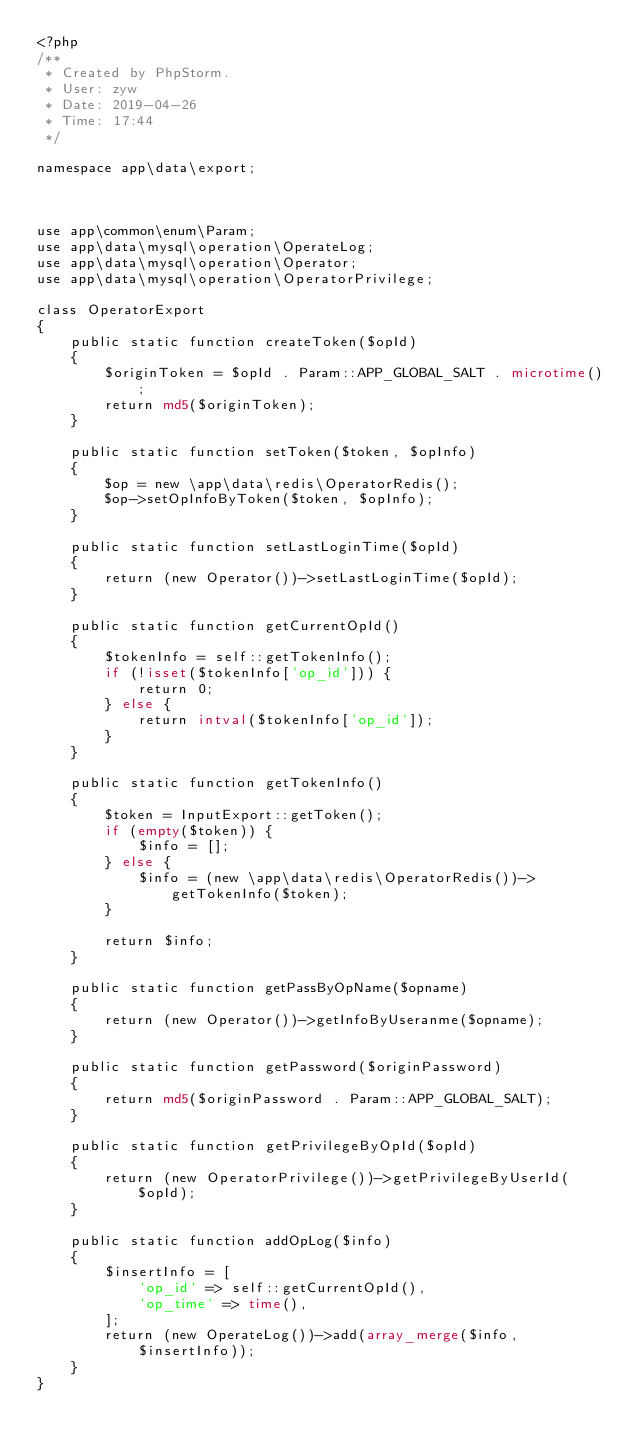Convert code to text. <code><loc_0><loc_0><loc_500><loc_500><_PHP_><?php
/**
 * Created by PhpStorm.
 * User: zyw
 * Date: 2019-04-26
 * Time: 17:44
 */

namespace app\data\export;



use app\common\enum\Param;
use app\data\mysql\operation\OperateLog;
use app\data\mysql\operation\Operator;
use app\data\mysql\operation\OperatorPrivilege;

class OperatorExport
{
    public static function createToken($opId)
    {
        $originToken = $opId . Param::APP_GLOBAL_SALT . microtime();
        return md5($originToken);
    }

    public static function setToken($token, $opInfo)
    {
        $op = new \app\data\redis\OperatorRedis();
        $op->setOpInfoByToken($token, $opInfo);
    }

    public static function setLastLoginTime($opId)
    {
        return (new Operator())->setLastLoginTime($opId);
    }

    public static function getCurrentOpId()
    {
        $tokenInfo = self::getTokenInfo();
        if (!isset($tokenInfo['op_id'])) {
            return 0;
        } else {
            return intval($tokenInfo['op_id']);
        }
    }

    public static function getTokenInfo()
    {
        $token = InputExport::getToken();
        if (empty($token)) {
            $info = [];
        } else {
            $info = (new \app\data\redis\OperatorRedis())->getTokenInfo($token);
        }

        return $info;
    }

    public static function getPassByOpName($opname)
    {
        return (new Operator())->getInfoByUseranme($opname);
    }

    public static function getPassword($originPassword)
    {
        return md5($originPassword . Param::APP_GLOBAL_SALT);
    }

    public static function getPrivilegeByOpId($opId)
    {
        return (new OperatorPrivilege())->getPrivilegeByUserId($opId);
    }

    public static function addOpLog($info)
    {
        $insertInfo = [
            'op_id' => self::getCurrentOpId(),
            'op_time' => time(),
        ];
        return (new OperateLog())->add(array_merge($info, $insertInfo));
    }
}</code> 